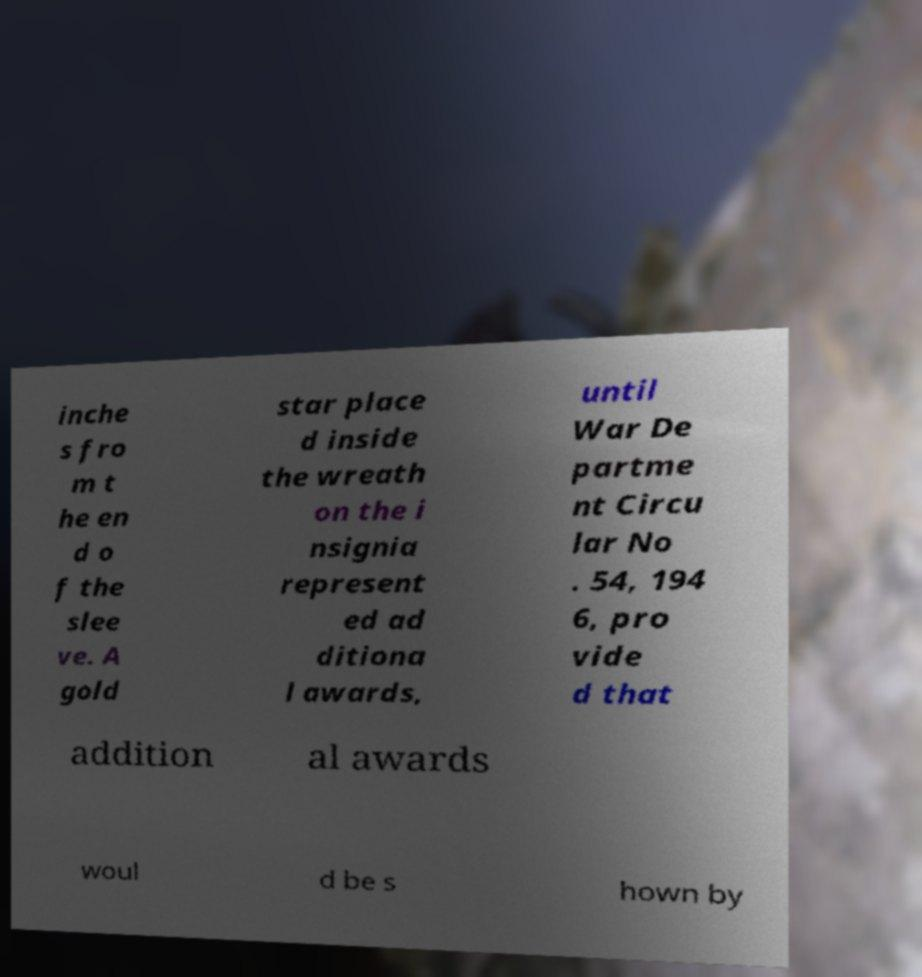For documentation purposes, I need the text within this image transcribed. Could you provide that? inche s fro m t he en d o f the slee ve. A gold star place d inside the wreath on the i nsignia represent ed ad ditiona l awards, until War De partme nt Circu lar No . 54, 194 6, pro vide d that addition al awards woul d be s hown by 